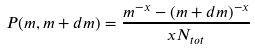<formula> <loc_0><loc_0><loc_500><loc_500>P ( m , m + d m ) = \frac { m ^ { - x } - ( m + d m ) ^ { - x } } { x N _ { t o t } }</formula> 